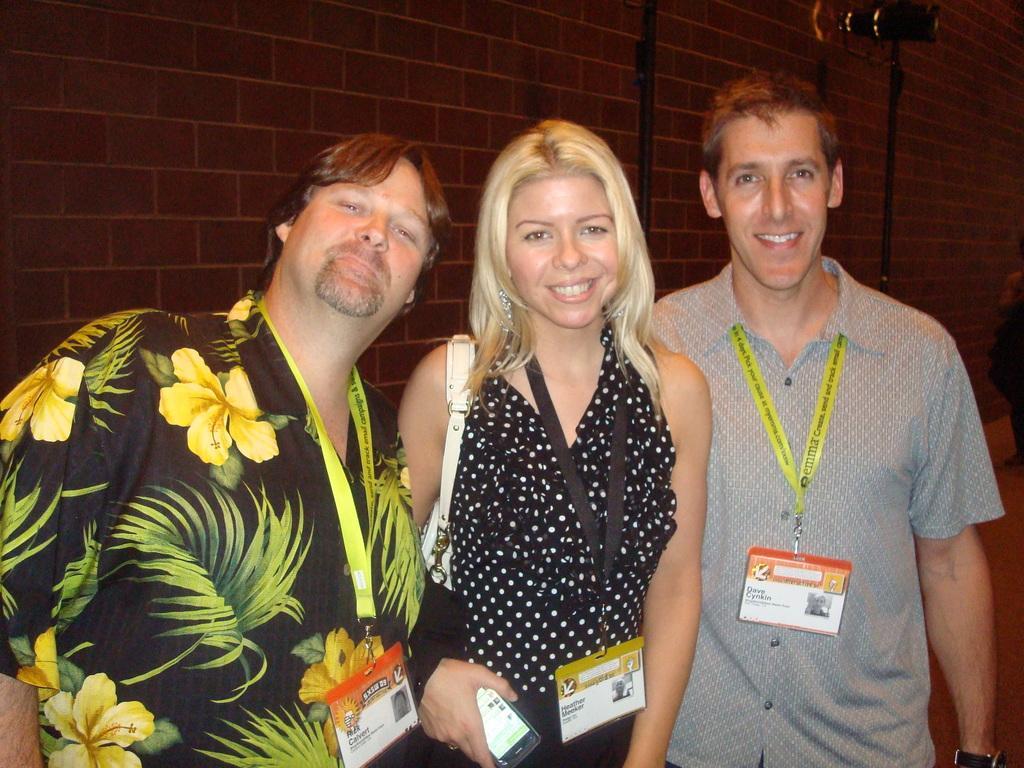Could you give a brief overview of what you see in this image? There are three persons. On the left end a person wearing a floral shirt and a tag. Middle a lady is wearing a tag and holding a mobile. In the right end person wearing a tag and a watch. In the background there is a red brick wall. 